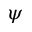Convert formula to latex. <formula><loc_0><loc_0><loc_500><loc_500>\psi</formula> 